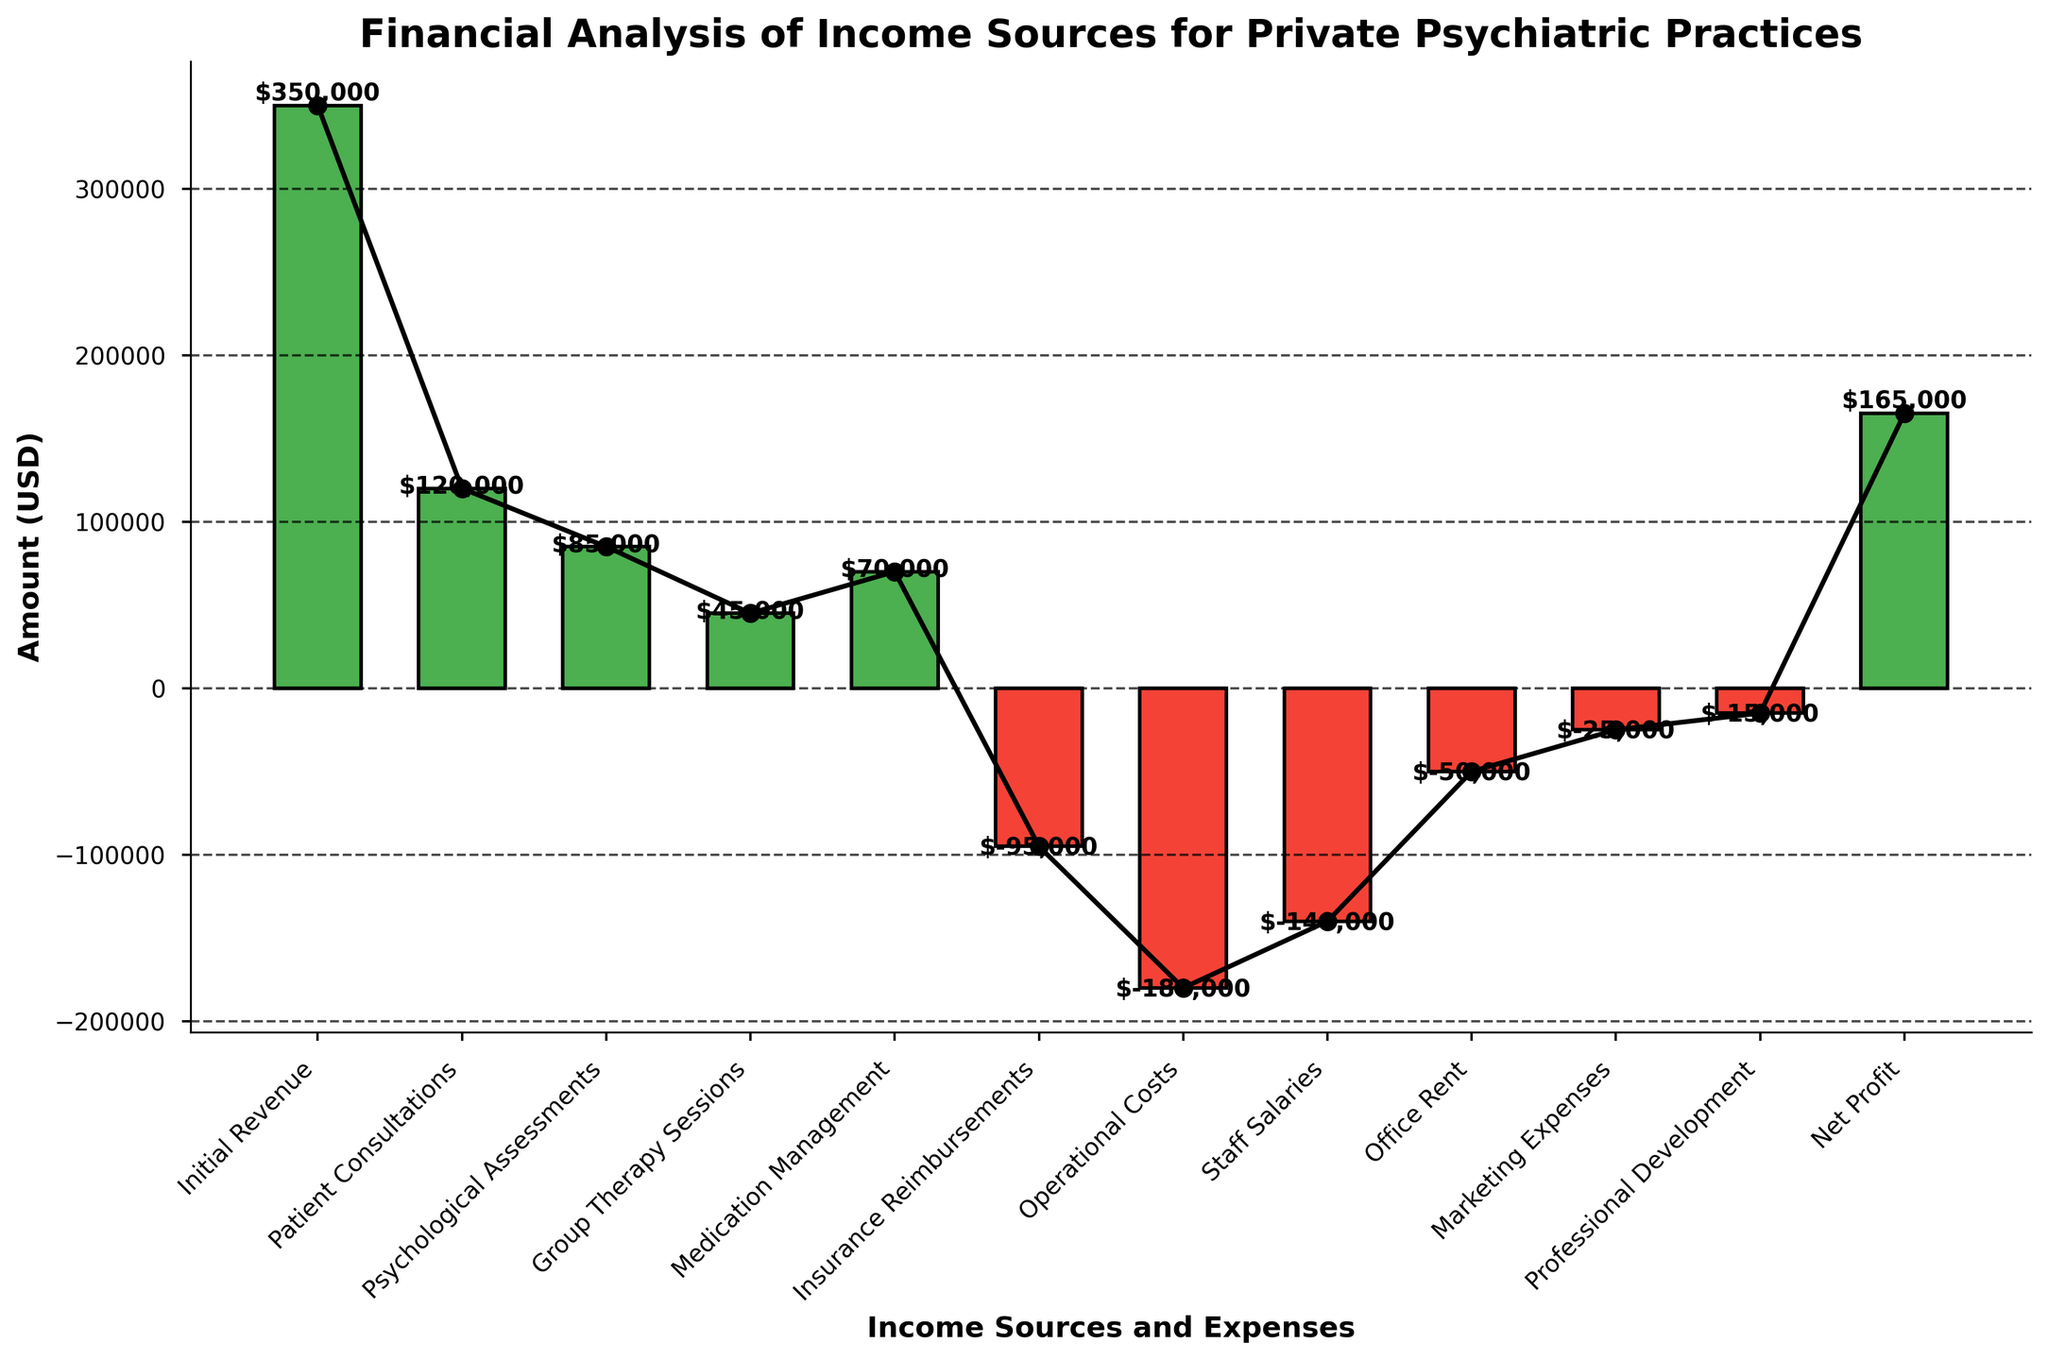what is the initial revenue amount stated in the chart? Initial Revenue is positioned as the starting point in the waterfall chart. The text label at this bar shows $350,000.
Answer: $350,000 what color represents negative financial values in the chart? Negative financial values are indicated by red-colored bars, showing losses or expenses.
Answer: Red which category has the highest single positive amount after Initial Revenue? By observing the chart, Patient Consultations show the highest positive bar after Initial Revenue, with an amount of $120,000.
Answer: Patient Consultations which three categories collectively contribute the most expense, and how much is the total expense for these categories? From the chart, Operational Costs, Staff Salaries, and Office Rent have negative amounts -$180,000, -$140,000, and -$50,000 respectively. Summing these equals (-$180,000) + (-$140,000) + (-$50,000) = -$370,000.
Answer: Operational Costs, Staff Salaries, Office Rent, and -$370,000 what is the net profit shown at the end of the chart? The Net Profit is the final bar on the waterfall chart, labeled $165,000 at its top.
Answer: $165,000 how do marketing expenses compare to professional development expenses? By reviewing the chart, Marketing Expenses are shown as -$25,000 and Professional Development Expenses as -$15,000. Thus, Marketing Expenses are $10,000 more than Professional Development Expenses.
Answer: $10,000 more what total amount do patient consultations, psychological assessments, and group therapy sessions contribute? Adding these amounts from the chart: Patient Consultations ($120,000) + Psychological Assessments ($85,000) + Group Therapy Sessions ($45,000) equals $250,000.
Answer: $250,000 which component between insurance reimbursements and medication management has a net-negative influence on the revenue, and by how much? The chart shows Insurance Reimbursements as -$95,000 and Medication Management as $70,000. The net-negative influence is by Insurance Reimbursements which is -$95,000.
Answer: Insurance Reimbursements, -$95,000 summarize the cumulative impact of operational costs and office rent on revenue Operational Costs (-$180,000) and Office Rent (-$50,000) together result in a cumulative reduction of ($180,000 + $50,000) $230,000 on revenue.
Answer: -$230,000 